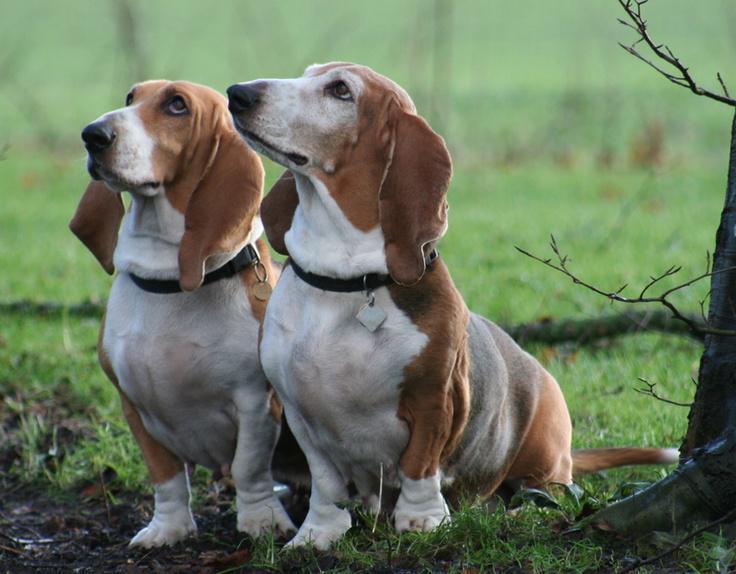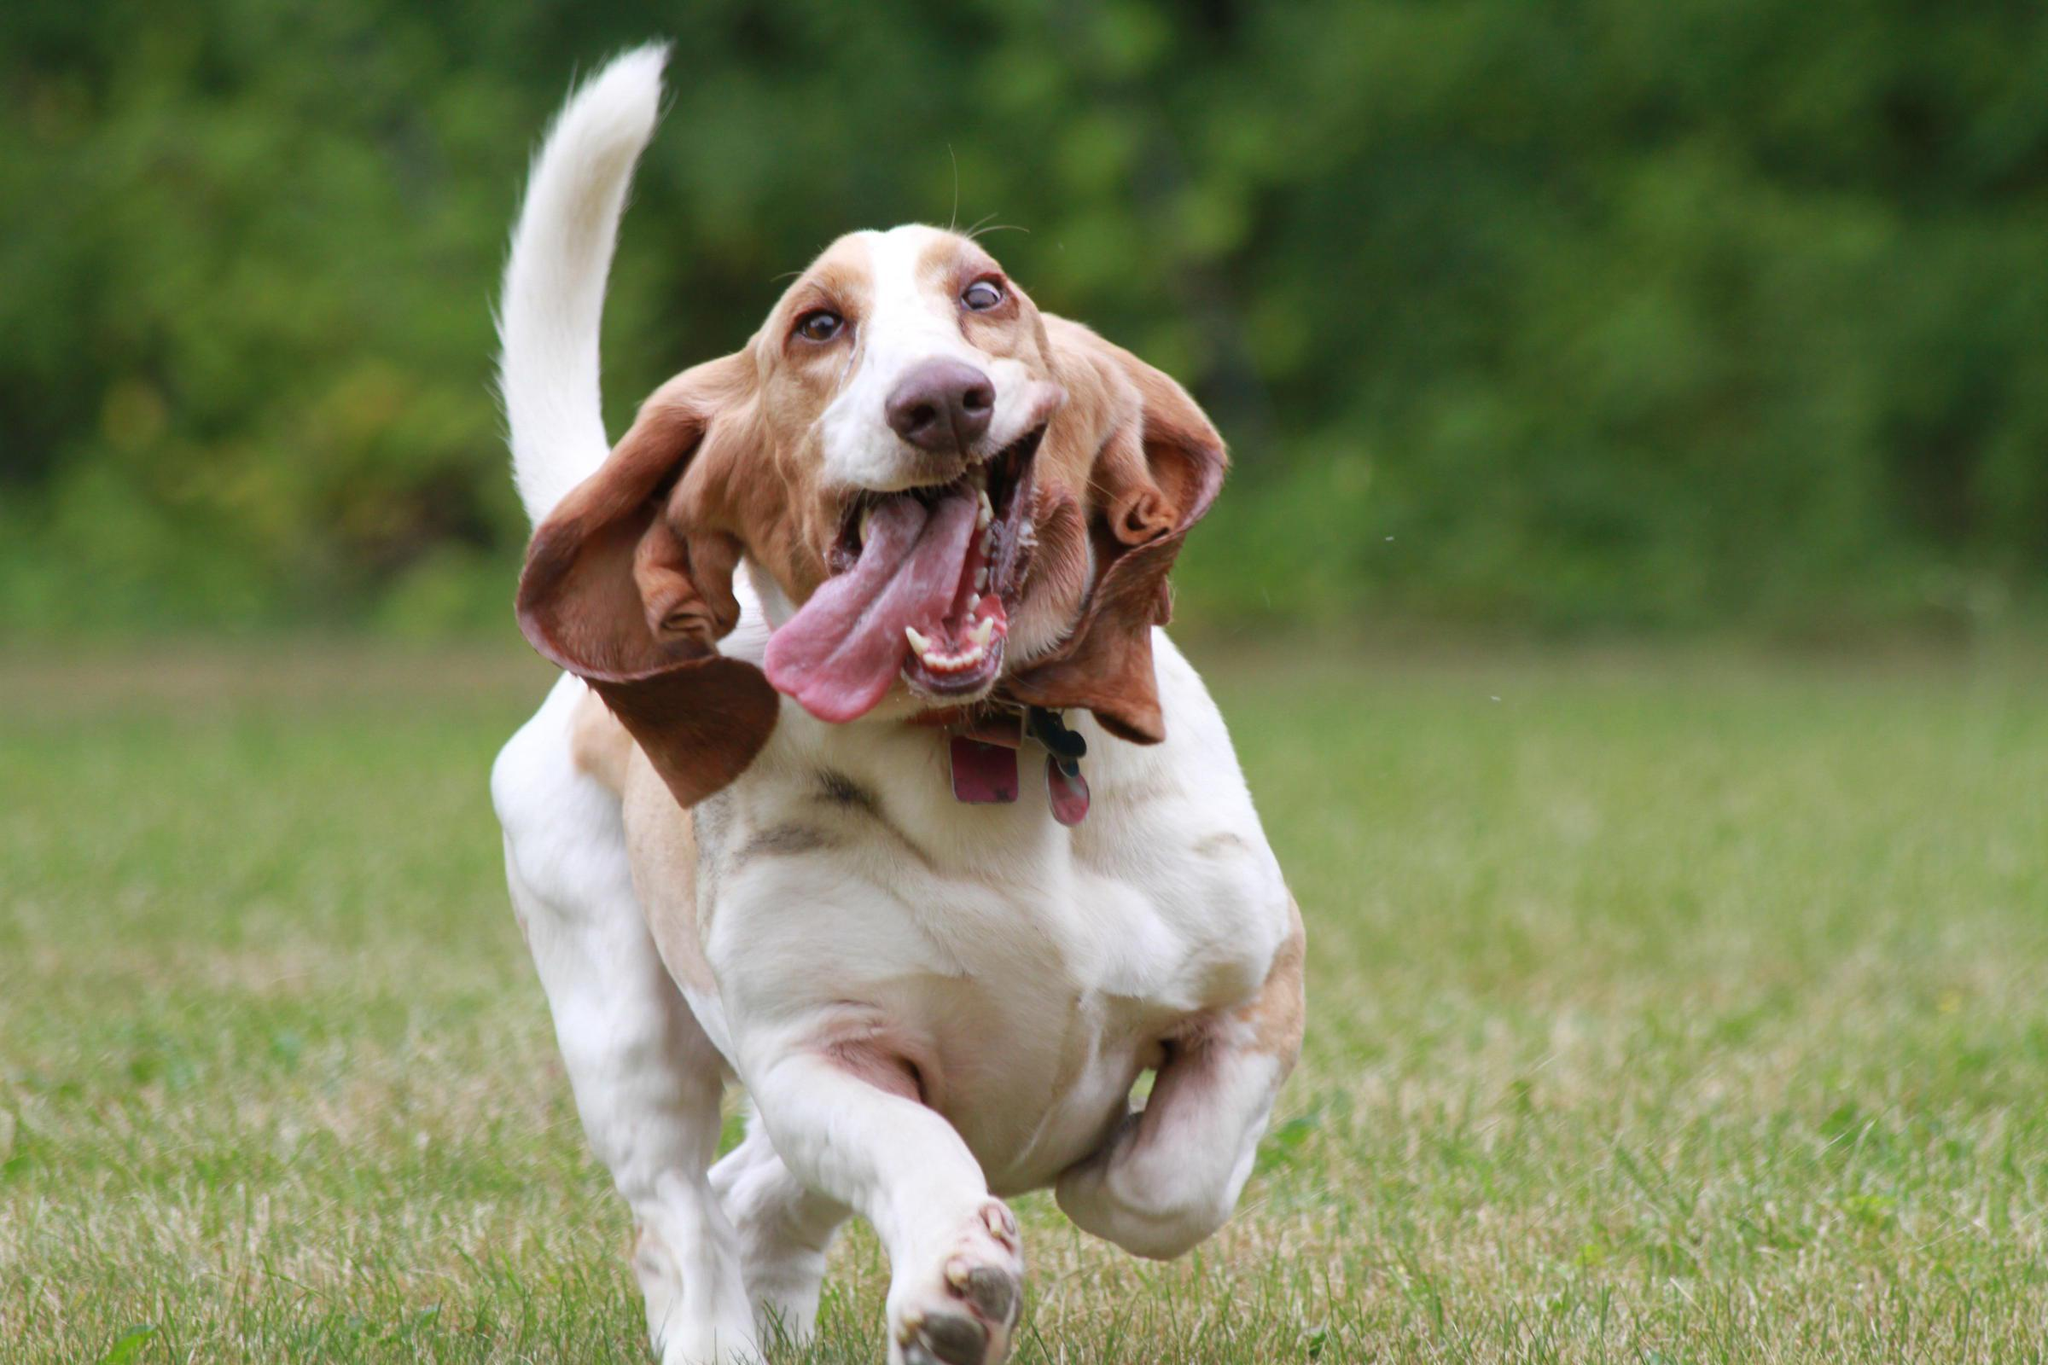The first image is the image on the left, the second image is the image on the right. For the images displayed, is the sentence "The dog in the image on the right is running toward the camera." factually correct? Answer yes or no. Yes. 